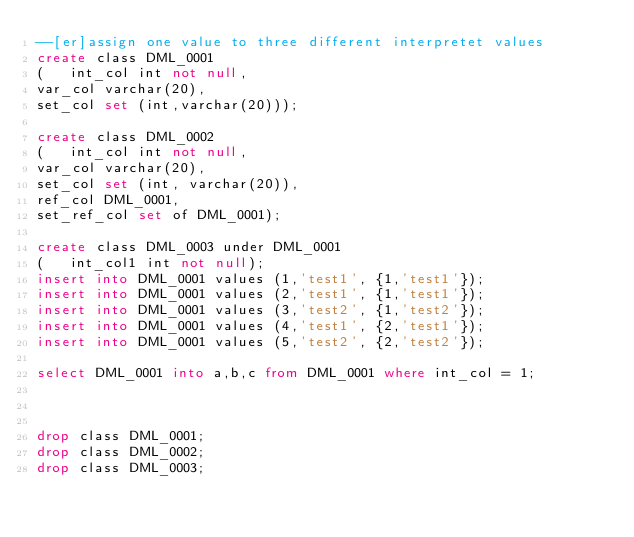<code> <loc_0><loc_0><loc_500><loc_500><_SQL_>--[er]assign one value to three different interpretet values 
create class DML_0001
( 	int_col int not null,
var_col varchar(20),
set_col set (int,varchar(20)));

create class DML_0002 	
(	int_col int not null,
var_col varchar(20),
set_col set (int, varchar(20)),
ref_col DML_0001,
set_ref_col set of DML_0001);

create class DML_0003 under DML_0001
( 	int_col1 int not null);
insert into DML_0001 values (1,'test1', {1,'test1'});
insert into DML_0001 values (2,'test1', {1,'test1'});
insert into DML_0001 values (3,'test2', {1,'test2'});
insert into DML_0001 values (4,'test1', {2,'test1'});
insert into DML_0001 values (5,'test2', {2,'test2'});

select DML_0001 into a,b,c from DML_0001 where int_col = 1;



drop class DML_0001;
drop class DML_0002;
drop class DML_0003;
</code> 